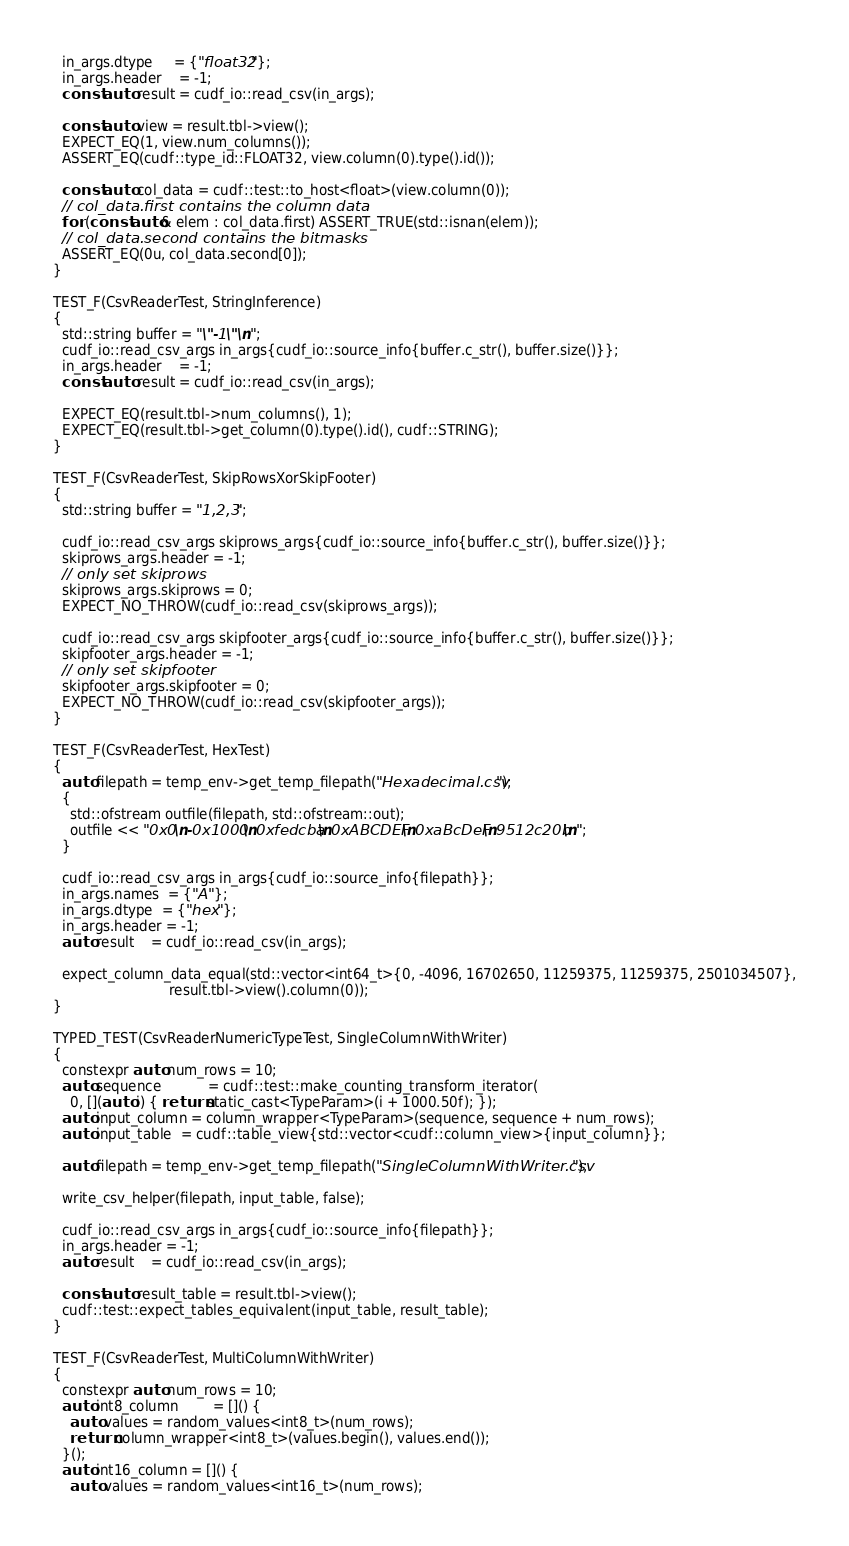Convert code to text. <code><loc_0><loc_0><loc_500><loc_500><_Cuda_>  in_args.dtype     = {"float32"};
  in_args.header    = -1;
  const auto result = cudf_io::read_csv(in_args);

  const auto view = result.tbl->view();
  EXPECT_EQ(1, view.num_columns());
  ASSERT_EQ(cudf::type_id::FLOAT32, view.column(0).type().id());

  const auto col_data = cudf::test::to_host<float>(view.column(0));
  // col_data.first contains the column data
  for (const auto& elem : col_data.first) ASSERT_TRUE(std::isnan(elem));
  // col_data.second contains the bitmasks
  ASSERT_EQ(0u, col_data.second[0]);
}

TEST_F(CsvReaderTest, StringInference)
{
  std::string buffer = "\"-1\"\n";
  cudf_io::read_csv_args in_args{cudf_io::source_info{buffer.c_str(), buffer.size()}};
  in_args.header    = -1;
  const auto result = cudf_io::read_csv(in_args);

  EXPECT_EQ(result.tbl->num_columns(), 1);
  EXPECT_EQ(result.tbl->get_column(0).type().id(), cudf::STRING);
}

TEST_F(CsvReaderTest, SkipRowsXorSkipFooter)
{
  std::string buffer = "1,2,3";

  cudf_io::read_csv_args skiprows_args{cudf_io::source_info{buffer.c_str(), buffer.size()}};
  skiprows_args.header = -1;
  // only set skiprows
  skiprows_args.skiprows = 0;
  EXPECT_NO_THROW(cudf_io::read_csv(skiprows_args));

  cudf_io::read_csv_args skipfooter_args{cudf_io::source_info{buffer.c_str(), buffer.size()}};
  skipfooter_args.header = -1;
  // only set skipfooter
  skipfooter_args.skipfooter = 0;
  EXPECT_NO_THROW(cudf_io::read_csv(skipfooter_args));
}

TEST_F(CsvReaderTest, HexTest)
{
  auto filepath = temp_env->get_temp_filepath("Hexadecimal.csv");
  {
    std::ofstream outfile(filepath, std::ofstream::out);
    outfile << "0x0\n-0x1000\n0xfedcba\n0xABCDEF\n0xaBcDeF\n9512c20b\n";
  }

  cudf_io::read_csv_args in_args{cudf_io::source_info{filepath}};
  in_args.names  = {"A"};
  in_args.dtype  = {"hex"};
  in_args.header = -1;
  auto result    = cudf_io::read_csv(in_args);

  expect_column_data_equal(std::vector<int64_t>{0, -4096, 16702650, 11259375, 11259375, 2501034507},
                           result.tbl->view().column(0));
}

TYPED_TEST(CsvReaderNumericTypeTest, SingleColumnWithWriter)
{
  constexpr auto num_rows = 10;
  auto sequence           = cudf::test::make_counting_transform_iterator(
    0, [](auto i) { return static_cast<TypeParam>(i + 1000.50f); });
  auto input_column = column_wrapper<TypeParam>(sequence, sequence + num_rows);
  auto input_table  = cudf::table_view{std::vector<cudf::column_view>{input_column}};

  auto filepath = temp_env->get_temp_filepath("SingleColumnWithWriter.csv");

  write_csv_helper(filepath, input_table, false);

  cudf_io::read_csv_args in_args{cudf_io::source_info{filepath}};
  in_args.header = -1;
  auto result    = cudf_io::read_csv(in_args);

  const auto result_table = result.tbl->view();
  cudf::test::expect_tables_equivalent(input_table, result_table);
}

TEST_F(CsvReaderTest, MultiColumnWithWriter)
{
  constexpr auto num_rows = 10;
  auto int8_column        = []() {
    auto values = random_values<int8_t>(num_rows);
    return column_wrapper<int8_t>(values.begin(), values.end());
  }();
  auto int16_column = []() {
    auto values = random_values<int16_t>(num_rows);</code> 